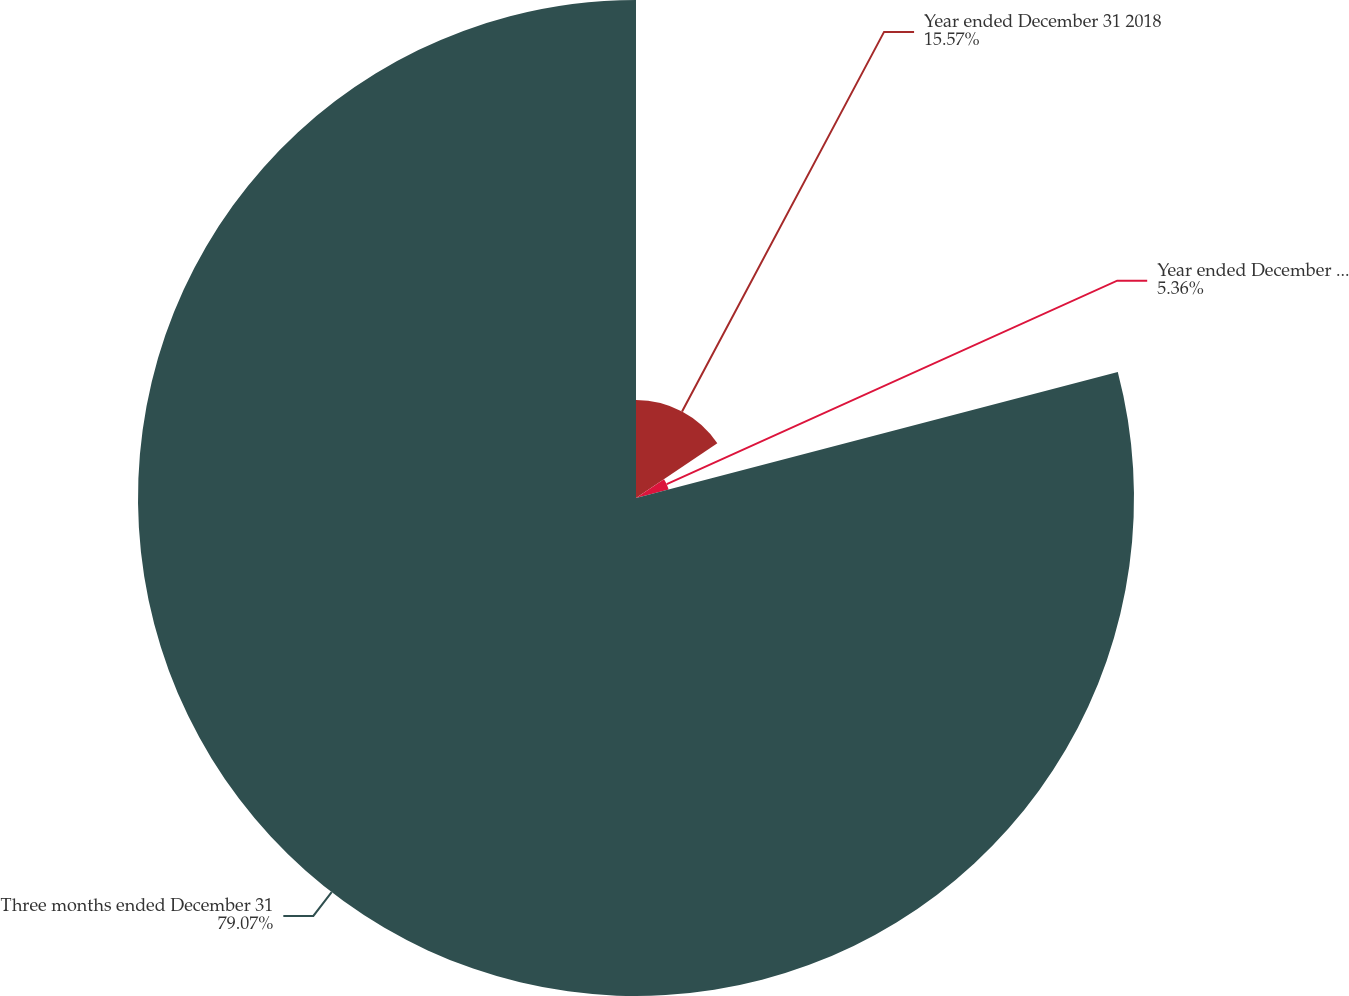<chart> <loc_0><loc_0><loc_500><loc_500><pie_chart><fcel>Year ended December 31 2018<fcel>Year ended December 31 2017<fcel>Three months ended December 31<nl><fcel>15.57%<fcel>5.36%<fcel>79.08%<nl></chart> 